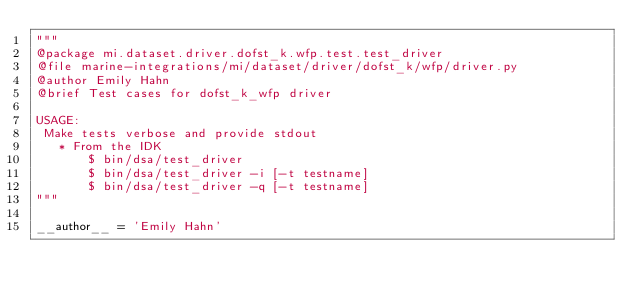Convert code to text. <code><loc_0><loc_0><loc_500><loc_500><_Python_>"""
@package mi.dataset.driver.dofst_k.wfp.test.test_driver
@file marine-integrations/mi/dataset/driver/dofst_k/wfp/driver.py
@author Emily Hahn
@brief Test cases for dofst_k_wfp driver

USAGE:
 Make tests verbose and provide stdout
   * From the IDK
       $ bin/dsa/test_driver
       $ bin/dsa/test_driver -i [-t testname]
       $ bin/dsa/test_driver -q [-t testname]
"""

__author__ = 'Emily Hahn'</code> 